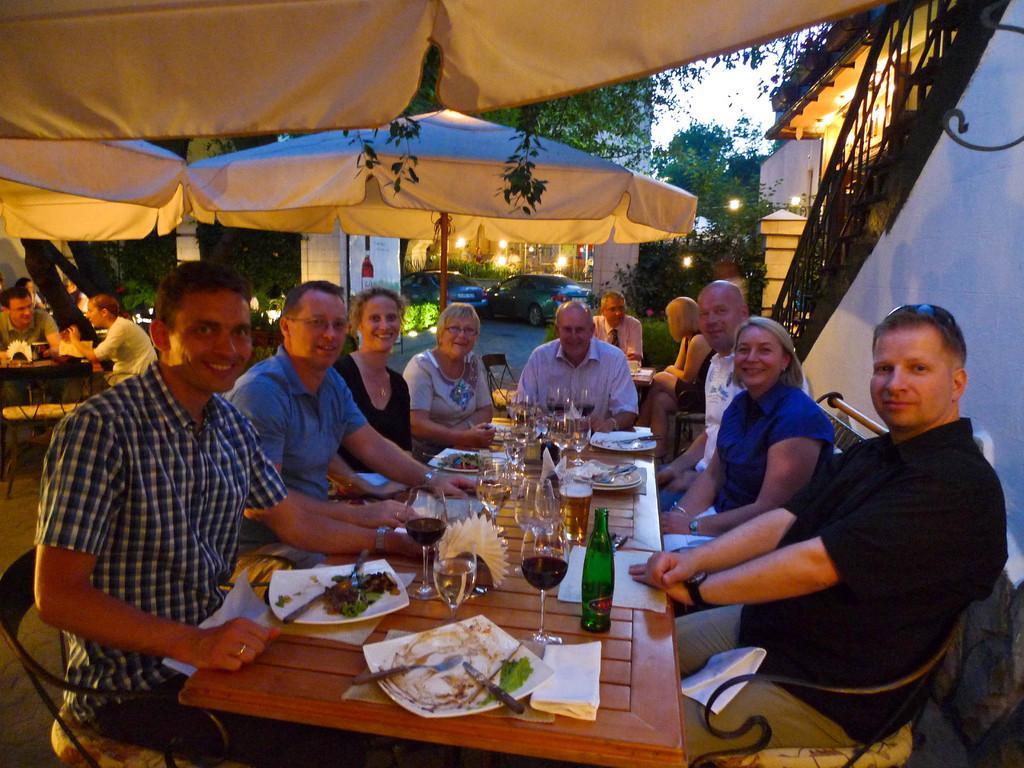Please provide a concise description of this image. As we can see in the image there is a sky, trees, light, umbrellas cars, few people sitting on chairs and there is a table. On table there is a plate, knife, tissue, glasses and bottles. 